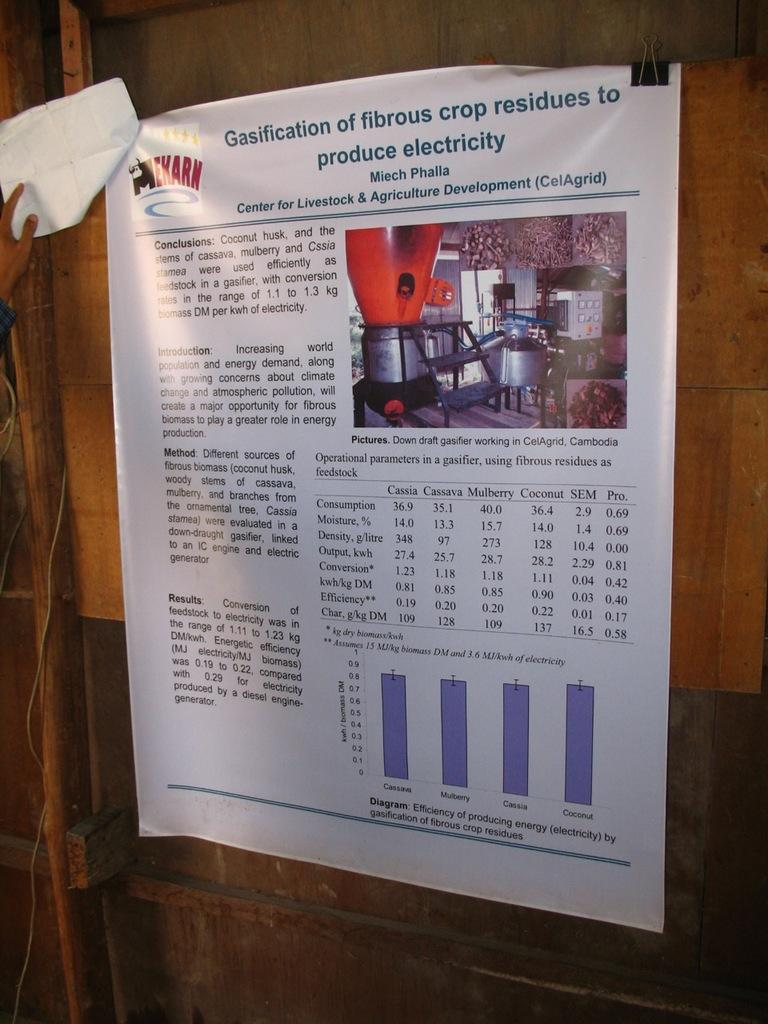Provide a one-sentence caption for the provided image. A poster explaining making electricity from crop residue is on a wooden panel. 